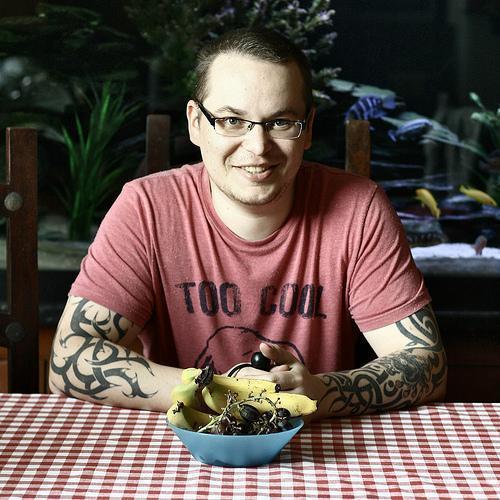How many dinosaurs are in the picture?
Give a very brief answer. 0. How many elephants are pictured?
Give a very brief answer. 0. How many bananas are there?
Give a very brief answer. 1. 